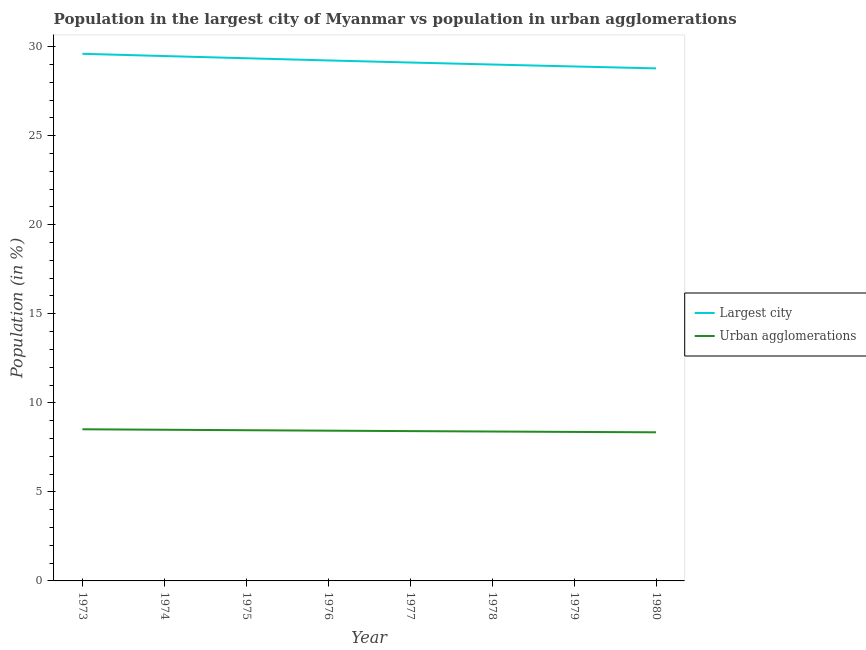Does the line corresponding to population in the largest city intersect with the line corresponding to population in urban agglomerations?
Make the answer very short. No. What is the population in urban agglomerations in 1974?
Make the answer very short. 8.49. Across all years, what is the maximum population in the largest city?
Give a very brief answer. 29.6. Across all years, what is the minimum population in urban agglomerations?
Ensure brevity in your answer.  8.35. In which year was the population in the largest city maximum?
Make the answer very short. 1973. In which year was the population in the largest city minimum?
Offer a very short reply. 1980. What is the total population in the largest city in the graph?
Offer a terse response. 233.41. What is the difference between the population in the largest city in 1975 and that in 1979?
Your response must be concise. 0.46. What is the difference between the population in urban agglomerations in 1979 and the population in the largest city in 1974?
Your response must be concise. -21.11. What is the average population in the largest city per year?
Your answer should be very brief. 29.18. In the year 1976, what is the difference between the population in urban agglomerations and population in the largest city?
Ensure brevity in your answer.  -20.79. In how many years, is the population in urban agglomerations greater than 28 %?
Provide a short and direct response. 0. What is the ratio of the population in the largest city in 1973 to that in 1975?
Your answer should be very brief. 1.01. What is the difference between the highest and the second highest population in the largest city?
Keep it short and to the point. 0.13. What is the difference between the highest and the lowest population in the largest city?
Ensure brevity in your answer.  0.82. In how many years, is the population in urban agglomerations greater than the average population in urban agglomerations taken over all years?
Give a very brief answer. 4. Is the sum of the population in the largest city in 1975 and 1976 greater than the maximum population in urban agglomerations across all years?
Offer a terse response. Yes. Does the population in the largest city monotonically increase over the years?
Your answer should be very brief. No. What is the difference between two consecutive major ticks on the Y-axis?
Give a very brief answer. 5. Are the values on the major ticks of Y-axis written in scientific E-notation?
Ensure brevity in your answer.  No. Does the graph contain any zero values?
Offer a terse response. No. Does the graph contain grids?
Ensure brevity in your answer.  No. Where does the legend appear in the graph?
Make the answer very short. Center right. How many legend labels are there?
Your response must be concise. 2. What is the title of the graph?
Provide a short and direct response. Population in the largest city of Myanmar vs population in urban agglomerations. Does "Export" appear as one of the legend labels in the graph?
Your answer should be compact. No. What is the label or title of the X-axis?
Provide a short and direct response. Year. What is the label or title of the Y-axis?
Your answer should be compact. Population (in %). What is the Population (in %) in Largest city in 1973?
Offer a very short reply. 29.6. What is the Population (in %) in Urban agglomerations in 1973?
Your answer should be compact. 8.51. What is the Population (in %) of Largest city in 1974?
Ensure brevity in your answer.  29.47. What is the Population (in %) of Urban agglomerations in 1974?
Give a very brief answer. 8.49. What is the Population (in %) of Largest city in 1975?
Provide a short and direct response. 29.35. What is the Population (in %) in Urban agglomerations in 1975?
Your answer should be compact. 8.46. What is the Population (in %) in Largest city in 1976?
Offer a very short reply. 29.23. What is the Population (in %) of Urban agglomerations in 1976?
Your answer should be very brief. 8.44. What is the Population (in %) of Largest city in 1977?
Offer a terse response. 29.11. What is the Population (in %) in Urban agglomerations in 1977?
Ensure brevity in your answer.  8.41. What is the Population (in %) of Largest city in 1978?
Make the answer very short. 29. What is the Population (in %) in Urban agglomerations in 1978?
Make the answer very short. 8.39. What is the Population (in %) in Largest city in 1979?
Make the answer very short. 28.89. What is the Population (in %) of Urban agglomerations in 1979?
Your answer should be very brief. 8.37. What is the Population (in %) in Largest city in 1980?
Ensure brevity in your answer.  28.78. What is the Population (in %) of Urban agglomerations in 1980?
Offer a very short reply. 8.35. Across all years, what is the maximum Population (in %) of Largest city?
Provide a short and direct response. 29.6. Across all years, what is the maximum Population (in %) of Urban agglomerations?
Your response must be concise. 8.51. Across all years, what is the minimum Population (in %) of Largest city?
Your answer should be very brief. 28.78. Across all years, what is the minimum Population (in %) in Urban agglomerations?
Offer a very short reply. 8.35. What is the total Population (in %) in Largest city in the graph?
Offer a terse response. 233.41. What is the total Population (in %) of Urban agglomerations in the graph?
Offer a terse response. 67.41. What is the difference between the Population (in %) in Largest city in 1973 and that in 1974?
Make the answer very short. 0.13. What is the difference between the Population (in %) in Urban agglomerations in 1973 and that in 1974?
Make the answer very short. 0.03. What is the difference between the Population (in %) in Largest city in 1973 and that in 1975?
Ensure brevity in your answer.  0.25. What is the difference between the Population (in %) in Urban agglomerations in 1973 and that in 1975?
Provide a succinct answer. 0.05. What is the difference between the Population (in %) in Largest city in 1973 and that in 1976?
Your answer should be very brief. 0.37. What is the difference between the Population (in %) of Urban agglomerations in 1973 and that in 1976?
Your answer should be compact. 0.08. What is the difference between the Population (in %) in Largest city in 1973 and that in 1977?
Ensure brevity in your answer.  0.49. What is the difference between the Population (in %) of Urban agglomerations in 1973 and that in 1977?
Provide a succinct answer. 0.1. What is the difference between the Population (in %) of Largest city in 1973 and that in 1978?
Provide a succinct answer. 0.6. What is the difference between the Population (in %) in Urban agglomerations in 1973 and that in 1978?
Make the answer very short. 0.13. What is the difference between the Population (in %) of Largest city in 1973 and that in 1979?
Make the answer very short. 0.71. What is the difference between the Population (in %) of Urban agglomerations in 1973 and that in 1979?
Ensure brevity in your answer.  0.15. What is the difference between the Population (in %) in Largest city in 1973 and that in 1980?
Provide a short and direct response. 0.82. What is the difference between the Population (in %) of Urban agglomerations in 1973 and that in 1980?
Provide a short and direct response. 0.17. What is the difference between the Population (in %) in Largest city in 1974 and that in 1975?
Make the answer very short. 0.12. What is the difference between the Population (in %) in Urban agglomerations in 1974 and that in 1975?
Provide a short and direct response. 0.03. What is the difference between the Population (in %) of Largest city in 1974 and that in 1976?
Your answer should be very brief. 0.25. What is the difference between the Population (in %) of Urban agglomerations in 1974 and that in 1976?
Keep it short and to the point. 0.05. What is the difference between the Population (in %) of Largest city in 1974 and that in 1977?
Keep it short and to the point. 0.36. What is the difference between the Population (in %) of Urban agglomerations in 1974 and that in 1977?
Keep it short and to the point. 0.08. What is the difference between the Population (in %) of Largest city in 1974 and that in 1978?
Your response must be concise. 0.48. What is the difference between the Population (in %) of Urban agglomerations in 1974 and that in 1978?
Make the answer very short. 0.1. What is the difference between the Population (in %) of Largest city in 1974 and that in 1979?
Offer a terse response. 0.59. What is the difference between the Population (in %) of Urban agglomerations in 1974 and that in 1979?
Offer a very short reply. 0.12. What is the difference between the Population (in %) in Largest city in 1974 and that in 1980?
Make the answer very short. 0.69. What is the difference between the Population (in %) in Urban agglomerations in 1974 and that in 1980?
Offer a very short reply. 0.14. What is the difference between the Population (in %) of Largest city in 1975 and that in 1976?
Offer a very short reply. 0.12. What is the difference between the Population (in %) in Urban agglomerations in 1975 and that in 1976?
Provide a short and direct response. 0.03. What is the difference between the Population (in %) of Largest city in 1975 and that in 1977?
Provide a short and direct response. 0.24. What is the difference between the Population (in %) in Urban agglomerations in 1975 and that in 1977?
Your answer should be compact. 0.05. What is the difference between the Population (in %) of Largest city in 1975 and that in 1978?
Provide a succinct answer. 0.35. What is the difference between the Population (in %) of Urban agglomerations in 1975 and that in 1978?
Ensure brevity in your answer.  0.07. What is the difference between the Population (in %) in Largest city in 1975 and that in 1979?
Your answer should be compact. 0.46. What is the difference between the Population (in %) of Urban agglomerations in 1975 and that in 1979?
Your response must be concise. 0.1. What is the difference between the Population (in %) of Largest city in 1975 and that in 1980?
Provide a short and direct response. 0.57. What is the difference between the Population (in %) of Urban agglomerations in 1975 and that in 1980?
Keep it short and to the point. 0.12. What is the difference between the Population (in %) in Largest city in 1976 and that in 1977?
Offer a very short reply. 0.12. What is the difference between the Population (in %) of Urban agglomerations in 1976 and that in 1977?
Your answer should be very brief. 0.02. What is the difference between the Population (in %) in Largest city in 1976 and that in 1978?
Your answer should be compact. 0.23. What is the difference between the Population (in %) of Urban agglomerations in 1976 and that in 1978?
Ensure brevity in your answer.  0.05. What is the difference between the Population (in %) in Largest city in 1976 and that in 1979?
Ensure brevity in your answer.  0.34. What is the difference between the Population (in %) in Urban agglomerations in 1976 and that in 1979?
Provide a succinct answer. 0.07. What is the difference between the Population (in %) of Largest city in 1976 and that in 1980?
Make the answer very short. 0.45. What is the difference between the Population (in %) of Urban agglomerations in 1976 and that in 1980?
Ensure brevity in your answer.  0.09. What is the difference between the Population (in %) in Largest city in 1977 and that in 1978?
Make the answer very short. 0.11. What is the difference between the Population (in %) of Urban agglomerations in 1977 and that in 1978?
Your answer should be very brief. 0.02. What is the difference between the Population (in %) in Largest city in 1977 and that in 1979?
Your answer should be compact. 0.22. What is the difference between the Population (in %) of Urban agglomerations in 1977 and that in 1979?
Ensure brevity in your answer.  0.05. What is the difference between the Population (in %) in Largest city in 1977 and that in 1980?
Provide a succinct answer. 0.33. What is the difference between the Population (in %) of Urban agglomerations in 1977 and that in 1980?
Provide a succinct answer. 0.07. What is the difference between the Population (in %) in Largest city in 1978 and that in 1979?
Ensure brevity in your answer.  0.11. What is the difference between the Population (in %) of Urban agglomerations in 1978 and that in 1979?
Provide a short and direct response. 0.02. What is the difference between the Population (in %) in Largest city in 1978 and that in 1980?
Offer a terse response. 0.22. What is the difference between the Population (in %) of Urban agglomerations in 1978 and that in 1980?
Your answer should be very brief. 0.04. What is the difference between the Population (in %) of Largest city in 1979 and that in 1980?
Offer a terse response. 0.11. What is the difference between the Population (in %) in Urban agglomerations in 1979 and that in 1980?
Your answer should be compact. 0.02. What is the difference between the Population (in %) of Largest city in 1973 and the Population (in %) of Urban agglomerations in 1974?
Ensure brevity in your answer.  21.11. What is the difference between the Population (in %) of Largest city in 1973 and the Population (in %) of Urban agglomerations in 1975?
Your answer should be very brief. 21.14. What is the difference between the Population (in %) of Largest city in 1973 and the Population (in %) of Urban agglomerations in 1976?
Provide a short and direct response. 21.16. What is the difference between the Population (in %) in Largest city in 1973 and the Population (in %) in Urban agglomerations in 1977?
Provide a short and direct response. 21.19. What is the difference between the Population (in %) of Largest city in 1973 and the Population (in %) of Urban agglomerations in 1978?
Ensure brevity in your answer.  21.21. What is the difference between the Population (in %) of Largest city in 1973 and the Population (in %) of Urban agglomerations in 1979?
Provide a succinct answer. 21.23. What is the difference between the Population (in %) of Largest city in 1973 and the Population (in %) of Urban agglomerations in 1980?
Your response must be concise. 21.25. What is the difference between the Population (in %) of Largest city in 1974 and the Population (in %) of Urban agglomerations in 1975?
Give a very brief answer. 21.01. What is the difference between the Population (in %) in Largest city in 1974 and the Population (in %) in Urban agglomerations in 1976?
Keep it short and to the point. 21.04. What is the difference between the Population (in %) of Largest city in 1974 and the Population (in %) of Urban agglomerations in 1977?
Ensure brevity in your answer.  21.06. What is the difference between the Population (in %) in Largest city in 1974 and the Population (in %) in Urban agglomerations in 1978?
Make the answer very short. 21.08. What is the difference between the Population (in %) in Largest city in 1974 and the Population (in %) in Urban agglomerations in 1979?
Your response must be concise. 21.11. What is the difference between the Population (in %) in Largest city in 1974 and the Population (in %) in Urban agglomerations in 1980?
Provide a succinct answer. 21.13. What is the difference between the Population (in %) of Largest city in 1975 and the Population (in %) of Urban agglomerations in 1976?
Your answer should be very brief. 20.91. What is the difference between the Population (in %) of Largest city in 1975 and the Population (in %) of Urban agglomerations in 1977?
Your answer should be compact. 20.94. What is the difference between the Population (in %) of Largest city in 1975 and the Population (in %) of Urban agglomerations in 1978?
Your response must be concise. 20.96. What is the difference between the Population (in %) of Largest city in 1975 and the Population (in %) of Urban agglomerations in 1979?
Make the answer very short. 20.98. What is the difference between the Population (in %) in Largest city in 1975 and the Population (in %) in Urban agglomerations in 1980?
Keep it short and to the point. 21. What is the difference between the Population (in %) in Largest city in 1976 and the Population (in %) in Urban agglomerations in 1977?
Ensure brevity in your answer.  20.81. What is the difference between the Population (in %) of Largest city in 1976 and the Population (in %) of Urban agglomerations in 1978?
Offer a very short reply. 20.84. What is the difference between the Population (in %) of Largest city in 1976 and the Population (in %) of Urban agglomerations in 1979?
Your answer should be very brief. 20.86. What is the difference between the Population (in %) in Largest city in 1976 and the Population (in %) in Urban agglomerations in 1980?
Your answer should be very brief. 20.88. What is the difference between the Population (in %) of Largest city in 1977 and the Population (in %) of Urban agglomerations in 1978?
Provide a short and direct response. 20.72. What is the difference between the Population (in %) in Largest city in 1977 and the Population (in %) in Urban agglomerations in 1979?
Give a very brief answer. 20.74. What is the difference between the Population (in %) in Largest city in 1977 and the Population (in %) in Urban agglomerations in 1980?
Keep it short and to the point. 20.76. What is the difference between the Population (in %) of Largest city in 1978 and the Population (in %) of Urban agglomerations in 1979?
Keep it short and to the point. 20.63. What is the difference between the Population (in %) in Largest city in 1978 and the Population (in %) in Urban agglomerations in 1980?
Provide a short and direct response. 20.65. What is the difference between the Population (in %) in Largest city in 1979 and the Population (in %) in Urban agglomerations in 1980?
Your answer should be very brief. 20.54. What is the average Population (in %) of Largest city per year?
Offer a terse response. 29.18. What is the average Population (in %) of Urban agglomerations per year?
Make the answer very short. 8.43. In the year 1973, what is the difference between the Population (in %) in Largest city and Population (in %) in Urban agglomerations?
Your response must be concise. 21.08. In the year 1974, what is the difference between the Population (in %) in Largest city and Population (in %) in Urban agglomerations?
Keep it short and to the point. 20.98. In the year 1975, what is the difference between the Population (in %) in Largest city and Population (in %) in Urban agglomerations?
Your response must be concise. 20.89. In the year 1976, what is the difference between the Population (in %) in Largest city and Population (in %) in Urban agglomerations?
Offer a terse response. 20.79. In the year 1977, what is the difference between the Population (in %) in Largest city and Population (in %) in Urban agglomerations?
Your answer should be compact. 20.7. In the year 1978, what is the difference between the Population (in %) in Largest city and Population (in %) in Urban agglomerations?
Provide a succinct answer. 20.61. In the year 1979, what is the difference between the Population (in %) of Largest city and Population (in %) of Urban agglomerations?
Give a very brief answer. 20.52. In the year 1980, what is the difference between the Population (in %) of Largest city and Population (in %) of Urban agglomerations?
Provide a short and direct response. 20.43. What is the ratio of the Population (in %) in Largest city in 1973 to that in 1975?
Make the answer very short. 1.01. What is the ratio of the Population (in %) of Largest city in 1973 to that in 1976?
Ensure brevity in your answer.  1.01. What is the ratio of the Population (in %) of Urban agglomerations in 1973 to that in 1976?
Offer a terse response. 1.01. What is the ratio of the Population (in %) of Largest city in 1973 to that in 1977?
Your answer should be very brief. 1.02. What is the ratio of the Population (in %) of Urban agglomerations in 1973 to that in 1977?
Offer a very short reply. 1.01. What is the ratio of the Population (in %) in Largest city in 1973 to that in 1978?
Provide a short and direct response. 1.02. What is the ratio of the Population (in %) in Urban agglomerations in 1973 to that in 1978?
Your answer should be very brief. 1.01. What is the ratio of the Population (in %) of Largest city in 1973 to that in 1979?
Offer a terse response. 1.02. What is the ratio of the Population (in %) of Urban agglomerations in 1973 to that in 1979?
Your answer should be very brief. 1.02. What is the ratio of the Population (in %) of Largest city in 1973 to that in 1980?
Make the answer very short. 1.03. What is the ratio of the Population (in %) in Urban agglomerations in 1973 to that in 1980?
Keep it short and to the point. 1.02. What is the ratio of the Population (in %) of Largest city in 1974 to that in 1976?
Your response must be concise. 1.01. What is the ratio of the Population (in %) of Largest city in 1974 to that in 1977?
Ensure brevity in your answer.  1.01. What is the ratio of the Population (in %) of Urban agglomerations in 1974 to that in 1977?
Offer a terse response. 1.01. What is the ratio of the Population (in %) in Largest city in 1974 to that in 1978?
Provide a short and direct response. 1.02. What is the ratio of the Population (in %) in Urban agglomerations in 1974 to that in 1978?
Provide a short and direct response. 1.01. What is the ratio of the Population (in %) in Largest city in 1974 to that in 1979?
Ensure brevity in your answer.  1.02. What is the ratio of the Population (in %) of Urban agglomerations in 1974 to that in 1979?
Make the answer very short. 1.01. What is the ratio of the Population (in %) of Largest city in 1974 to that in 1980?
Give a very brief answer. 1.02. What is the ratio of the Population (in %) in Urban agglomerations in 1974 to that in 1980?
Give a very brief answer. 1.02. What is the ratio of the Population (in %) of Largest city in 1975 to that in 1976?
Give a very brief answer. 1. What is the ratio of the Population (in %) of Largest city in 1975 to that in 1977?
Your response must be concise. 1.01. What is the ratio of the Population (in %) of Urban agglomerations in 1975 to that in 1977?
Your answer should be very brief. 1.01. What is the ratio of the Population (in %) in Largest city in 1975 to that in 1978?
Ensure brevity in your answer.  1.01. What is the ratio of the Population (in %) of Urban agglomerations in 1975 to that in 1978?
Your response must be concise. 1.01. What is the ratio of the Population (in %) of Urban agglomerations in 1975 to that in 1979?
Offer a terse response. 1.01. What is the ratio of the Population (in %) in Largest city in 1975 to that in 1980?
Offer a very short reply. 1.02. What is the ratio of the Population (in %) in Urban agglomerations in 1975 to that in 1980?
Provide a short and direct response. 1.01. What is the ratio of the Population (in %) in Urban agglomerations in 1976 to that in 1977?
Offer a terse response. 1. What is the ratio of the Population (in %) in Largest city in 1976 to that in 1978?
Your answer should be very brief. 1.01. What is the ratio of the Population (in %) in Urban agglomerations in 1976 to that in 1978?
Give a very brief answer. 1.01. What is the ratio of the Population (in %) in Largest city in 1976 to that in 1979?
Offer a very short reply. 1.01. What is the ratio of the Population (in %) of Urban agglomerations in 1976 to that in 1979?
Your answer should be compact. 1.01. What is the ratio of the Population (in %) in Largest city in 1976 to that in 1980?
Provide a short and direct response. 1.02. What is the ratio of the Population (in %) in Urban agglomerations in 1976 to that in 1980?
Provide a succinct answer. 1.01. What is the ratio of the Population (in %) of Urban agglomerations in 1977 to that in 1978?
Make the answer very short. 1. What is the ratio of the Population (in %) in Largest city in 1977 to that in 1979?
Your answer should be very brief. 1.01. What is the ratio of the Population (in %) of Urban agglomerations in 1977 to that in 1979?
Make the answer very short. 1.01. What is the ratio of the Population (in %) in Largest city in 1977 to that in 1980?
Provide a short and direct response. 1.01. What is the ratio of the Population (in %) in Urban agglomerations in 1977 to that in 1980?
Your response must be concise. 1.01. What is the ratio of the Population (in %) of Largest city in 1978 to that in 1980?
Your response must be concise. 1.01. What is the ratio of the Population (in %) in Urban agglomerations in 1978 to that in 1980?
Offer a terse response. 1.01. What is the ratio of the Population (in %) in Urban agglomerations in 1979 to that in 1980?
Give a very brief answer. 1. What is the difference between the highest and the second highest Population (in %) in Largest city?
Your answer should be very brief. 0.13. What is the difference between the highest and the second highest Population (in %) of Urban agglomerations?
Provide a short and direct response. 0.03. What is the difference between the highest and the lowest Population (in %) in Largest city?
Offer a very short reply. 0.82. What is the difference between the highest and the lowest Population (in %) of Urban agglomerations?
Offer a terse response. 0.17. 